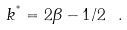Convert formula to latex. <formula><loc_0><loc_0><loc_500><loc_500>k ^ { ^ { * } } = 2 \beta - 1 / 2 \ .</formula> 